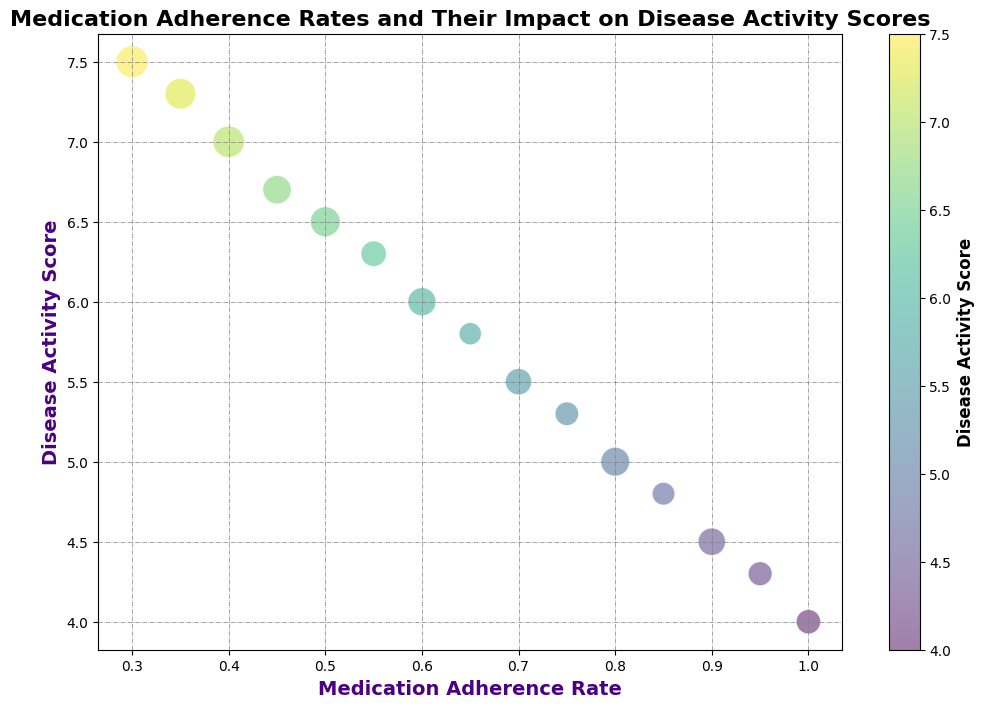What is the relationship between medication adherence rate and disease activity score? By examining the trend of the bubbles, a negative correlation is observed: as the medication adherence rate increases, the disease activity score tends to decrease.
Answer: Negative correlation Which medication adherence rate corresponds to the highest disease activity score? The bubble with the highest disease activity score (7.5) is located at a medication adherence rate of 0.3.
Answer: 0.3 What is the average disease activity score for patients with a medication adherence rate of 0.5 to 0.7? The scores for adherence rates 0.5, 0.6, and 0.7 are 6.5, 6.0, and 5.5 respectively. Average = (6.5 + 6.0 + 5.5) / 3 = 6.0
Answer: 6.0 Comparing medication adherence rates of 0.9 and 0.95, which one has a lower disease activity score? From the figure, the disease activity score for adherence rate 0.9 is 4.5, and for 0.95 it is 4.3. 4.3 is lower.
Answer: 0.95 What is the general trend in the size of the bubbles as the medication adherence rate increases from 0.4 to 1.0? Generally, the number of patients (indicated by bubble size) decreases as the medication adherence rate increases.
Answer: Decreasing Which adherence rate has more than 40 patients? The bubble sizes indicate more than 40 patients for adherence rates of 0.3, 0.4, and 0.45.
Answer: 0.3, 0.4, 0.45 Is the bubble for a medication adherence rate of 0.75 larger or smaller than the bubble for adherence rate 0.85? The bubble for 0.75 has 28 patients, and the bubble for 0.85 has 26 patients, indicating the bubble for 0.75 is slightly larger.
Answer: Larger Which medication adherence rate has the smallest number of patients? The smallest bubble on the chart corresponds to the medication adherence rate of 0.85 with 26 patients.
Answer: 0.85 What can be inferred about the disease activity scores for medication adherence rates below 0.4? Disease activity scores are highest for adherence rates below 0.4, indicating worse control of the disease.
Answer: Higher scores for lower adherence 